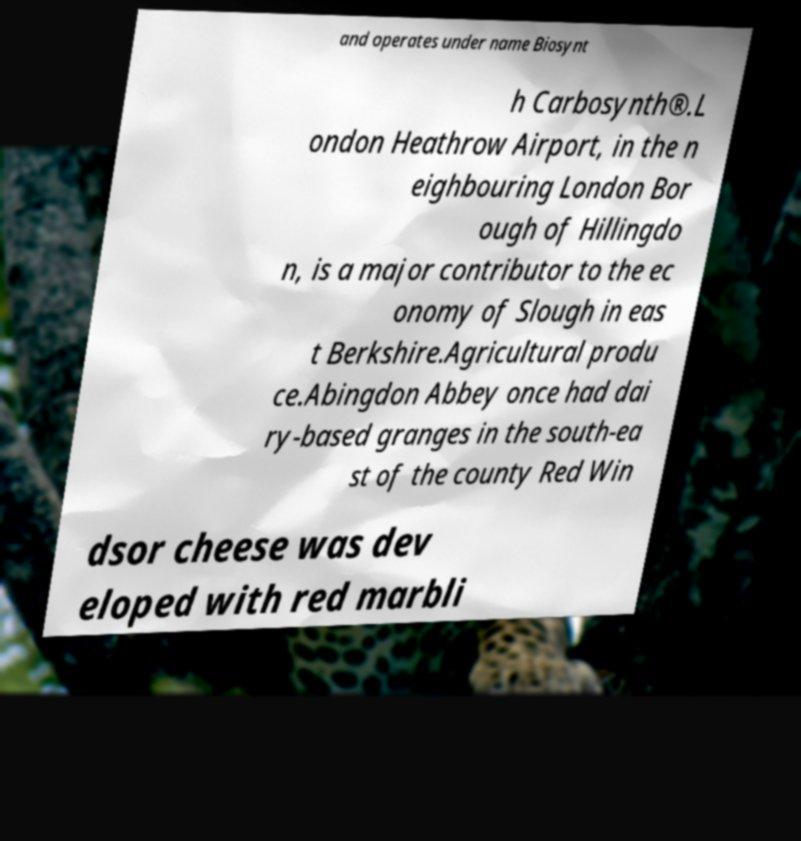Could you assist in decoding the text presented in this image and type it out clearly? and operates under name Biosynt h Carbosynth®.L ondon Heathrow Airport, in the n eighbouring London Bor ough of Hillingdo n, is a major contributor to the ec onomy of Slough in eas t Berkshire.Agricultural produ ce.Abingdon Abbey once had dai ry-based granges in the south-ea st of the county Red Win dsor cheese was dev eloped with red marbli 